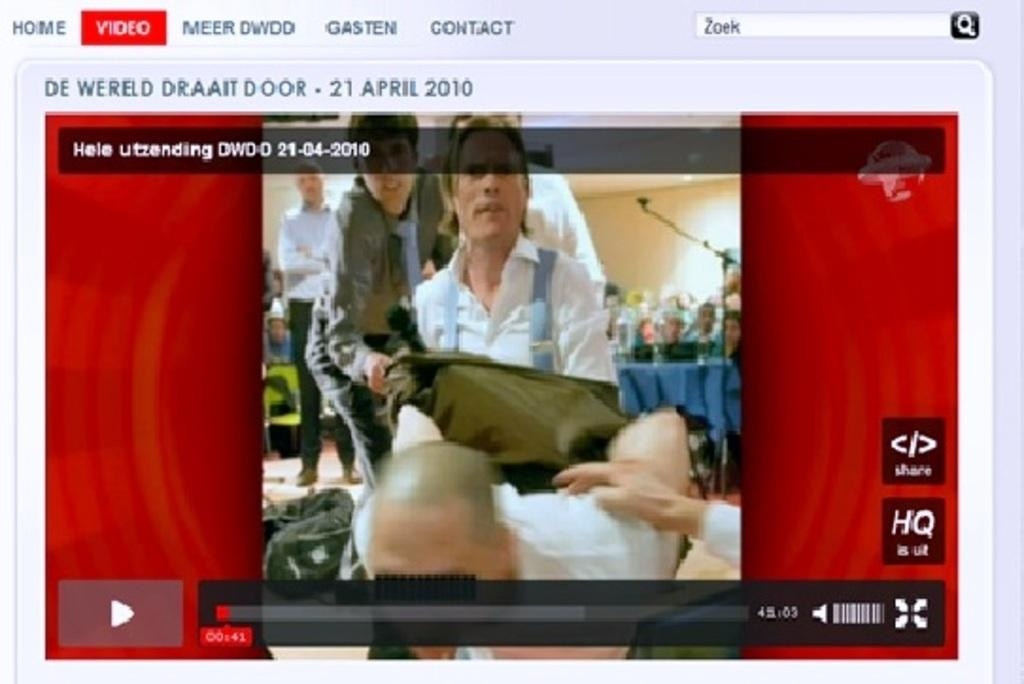<image>
Provide a brief description of the given image. A video is displayed from April 21 2010. 